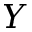Convert formula to latex. <formula><loc_0><loc_0><loc_500><loc_500>Y</formula> 